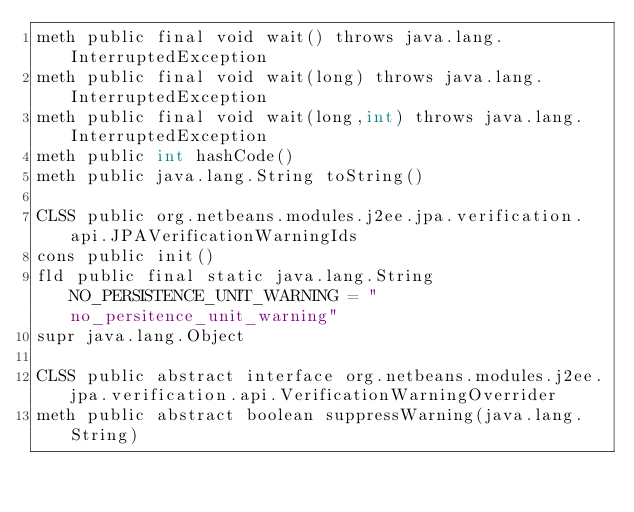<code> <loc_0><loc_0><loc_500><loc_500><_SML_>meth public final void wait() throws java.lang.InterruptedException
meth public final void wait(long) throws java.lang.InterruptedException
meth public final void wait(long,int) throws java.lang.InterruptedException
meth public int hashCode()
meth public java.lang.String toString()

CLSS public org.netbeans.modules.j2ee.jpa.verification.api.JPAVerificationWarningIds
cons public init()
fld public final static java.lang.String NO_PERSISTENCE_UNIT_WARNING = "no_persitence_unit_warning"
supr java.lang.Object

CLSS public abstract interface org.netbeans.modules.j2ee.jpa.verification.api.VerificationWarningOverrider
meth public abstract boolean suppressWarning(java.lang.String)

</code> 